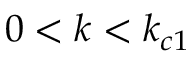Convert formula to latex. <formula><loc_0><loc_0><loc_500><loc_500>0 < k < k _ { c 1 }</formula> 